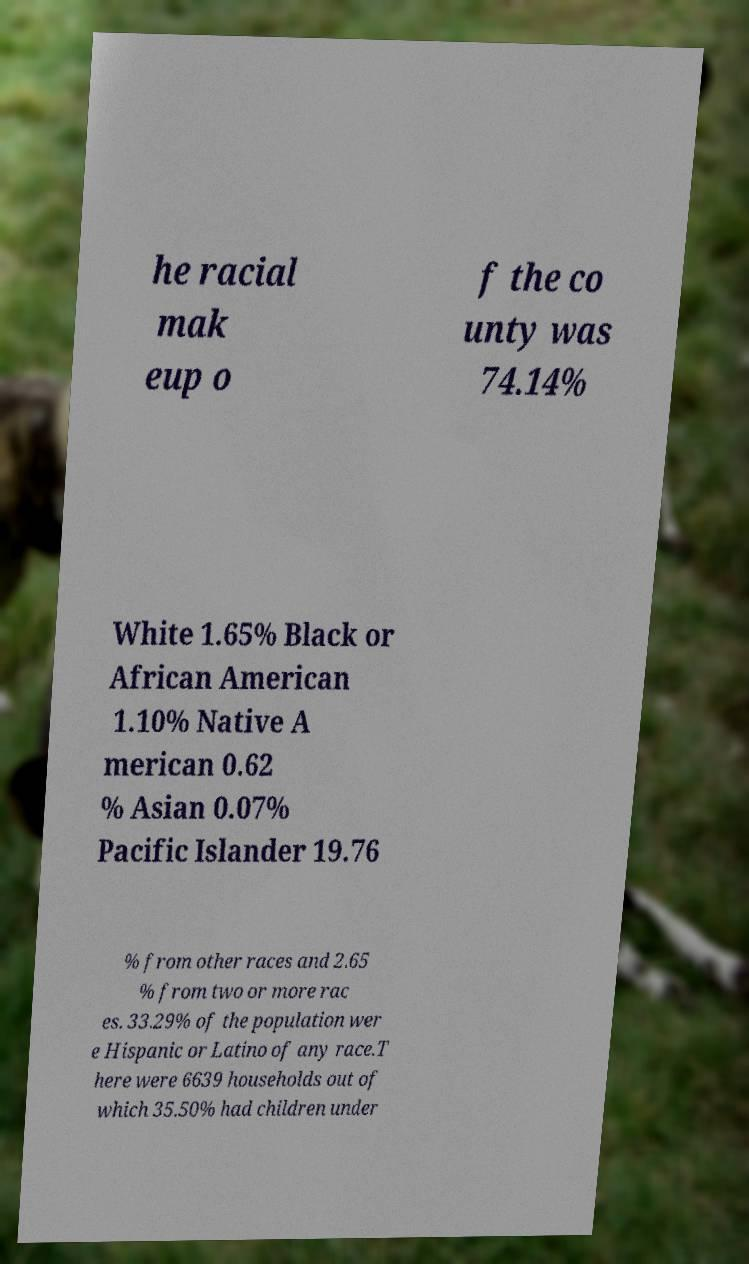Could you assist in decoding the text presented in this image and type it out clearly? he racial mak eup o f the co unty was 74.14% White 1.65% Black or African American 1.10% Native A merican 0.62 % Asian 0.07% Pacific Islander 19.76 % from other races and 2.65 % from two or more rac es. 33.29% of the population wer e Hispanic or Latino of any race.T here were 6639 households out of which 35.50% had children under 